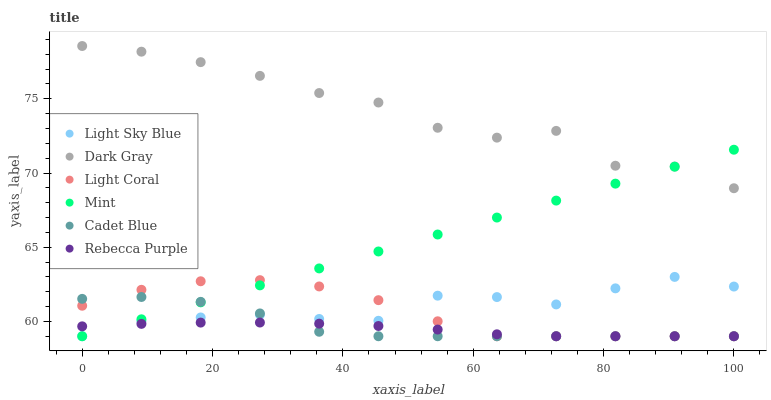Does Rebecca Purple have the minimum area under the curve?
Answer yes or no. Yes. Does Dark Gray have the maximum area under the curve?
Answer yes or no. Yes. Does Cadet Blue have the minimum area under the curve?
Answer yes or no. No. Does Cadet Blue have the maximum area under the curve?
Answer yes or no. No. Is Mint the smoothest?
Answer yes or no. Yes. Is Dark Gray the roughest?
Answer yes or no. Yes. Is Cadet Blue the smoothest?
Answer yes or no. No. Is Cadet Blue the roughest?
Answer yes or no. No. Does Light Coral have the lowest value?
Answer yes or no. Yes. Does Dark Gray have the lowest value?
Answer yes or no. No. Does Dark Gray have the highest value?
Answer yes or no. Yes. Does Cadet Blue have the highest value?
Answer yes or no. No. Is Light Sky Blue less than Dark Gray?
Answer yes or no. Yes. Is Dark Gray greater than Light Sky Blue?
Answer yes or no. Yes. Does Dark Gray intersect Mint?
Answer yes or no. Yes. Is Dark Gray less than Mint?
Answer yes or no. No. Is Dark Gray greater than Mint?
Answer yes or no. No. Does Light Sky Blue intersect Dark Gray?
Answer yes or no. No. 